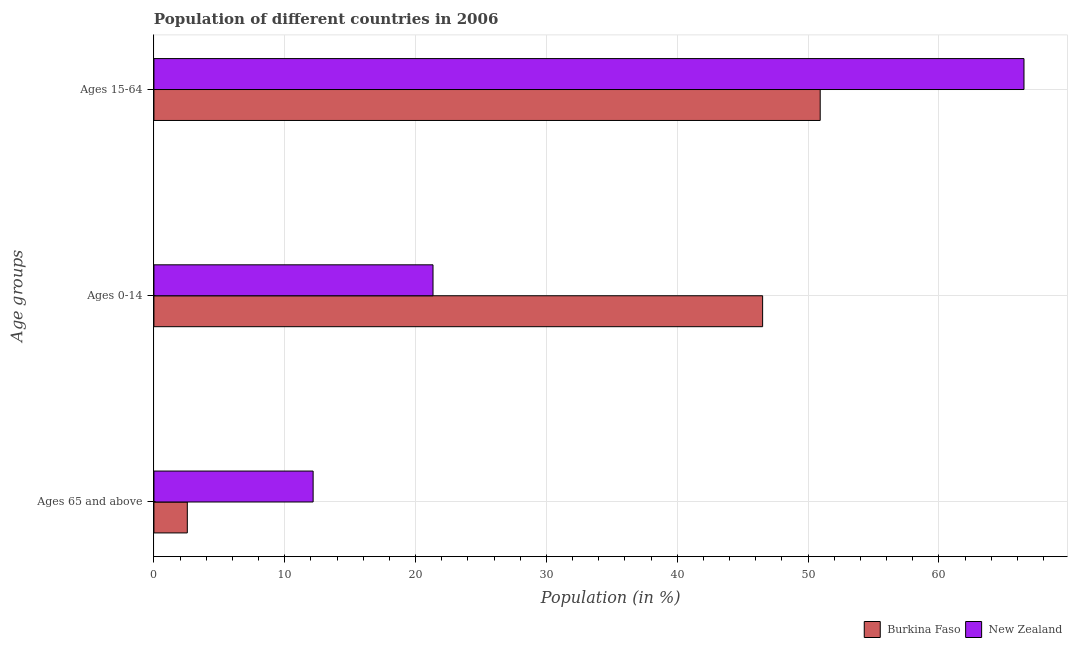How many groups of bars are there?
Your answer should be very brief. 3. Are the number of bars per tick equal to the number of legend labels?
Provide a succinct answer. Yes. How many bars are there on the 1st tick from the bottom?
Give a very brief answer. 2. What is the label of the 3rd group of bars from the top?
Offer a very short reply. Ages 65 and above. What is the percentage of population within the age-group of 65 and above in New Zealand?
Your answer should be very brief. 12.17. Across all countries, what is the maximum percentage of population within the age-group of 65 and above?
Offer a very short reply. 12.17. Across all countries, what is the minimum percentage of population within the age-group of 65 and above?
Keep it short and to the point. 2.55. In which country was the percentage of population within the age-group of 65 and above maximum?
Offer a terse response. New Zealand. In which country was the percentage of population within the age-group of 65 and above minimum?
Give a very brief answer. Burkina Faso. What is the total percentage of population within the age-group 0-14 in the graph?
Make the answer very short. 67.86. What is the difference between the percentage of population within the age-group of 65 and above in Burkina Faso and that in New Zealand?
Your answer should be compact. -9.62. What is the difference between the percentage of population within the age-group 0-14 in New Zealand and the percentage of population within the age-group 15-64 in Burkina Faso?
Offer a terse response. -29.59. What is the average percentage of population within the age-group of 65 and above per country?
Your answer should be compact. 7.36. What is the difference between the percentage of population within the age-group 0-14 and percentage of population within the age-group 15-64 in New Zealand?
Offer a very short reply. -45.17. In how many countries, is the percentage of population within the age-group 0-14 greater than 24 %?
Give a very brief answer. 1. What is the ratio of the percentage of population within the age-group 15-64 in New Zealand to that in Burkina Faso?
Your response must be concise. 1.31. Is the percentage of population within the age-group 0-14 in New Zealand less than that in Burkina Faso?
Your answer should be compact. Yes. What is the difference between the highest and the second highest percentage of population within the age-group 0-14?
Provide a short and direct response. 25.19. What is the difference between the highest and the lowest percentage of population within the age-group 15-64?
Your answer should be compact. 15.58. Is the sum of the percentage of population within the age-group of 65 and above in New Zealand and Burkina Faso greater than the maximum percentage of population within the age-group 0-14 across all countries?
Ensure brevity in your answer.  No. What does the 1st bar from the top in Ages 0-14 represents?
Ensure brevity in your answer.  New Zealand. What does the 1st bar from the bottom in Ages 65 and above represents?
Your answer should be very brief. Burkina Faso. Are the values on the major ticks of X-axis written in scientific E-notation?
Offer a terse response. No. Does the graph contain any zero values?
Give a very brief answer. No. How are the legend labels stacked?
Your response must be concise. Horizontal. What is the title of the graph?
Give a very brief answer. Population of different countries in 2006. Does "Moldova" appear as one of the legend labels in the graph?
Provide a succinct answer. No. What is the label or title of the X-axis?
Ensure brevity in your answer.  Population (in %). What is the label or title of the Y-axis?
Your response must be concise. Age groups. What is the Population (in %) in Burkina Faso in Ages 65 and above?
Your response must be concise. 2.55. What is the Population (in %) in New Zealand in Ages 65 and above?
Your answer should be very brief. 12.17. What is the Population (in %) in Burkina Faso in Ages 0-14?
Offer a very short reply. 46.52. What is the Population (in %) in New Zealand in Ages 0-14?
Your answer should be compact. 21.33. What is the Population (in %) in Burkina Faso in Ages 15-64?
Your response must be concise. 50.92. What is the Population (in %) in New Zealand in Ages 15-64?
Give a very brief answer. 66.5. Across all Age groups, what is the maximum Population (in %) in Burkina Faso?
Give a very brief answer. 50.92. Across all Age groups, what is the maximum Population (in %) in New Zealand?
Provide a short and direct response. 66.5. Across all Age groups, what is the minimum Population (in %) in Burkina Faso?
Make the answer very short. 2.55. Across all Age groups, what is the minimum Population (in %) of New Zealand?
Your response must be concise. 12.17. What is the total Population (in %) in Burkina Faso in the graph?
Your answer should be very brief. 100. What is the total Population (in %) in New Zealand in the graph?
Offer a terse response. 100. What is the difference between the Population (in %) in Burkina Faso in Ages 65 and above and that in Ages 0-14?
Your response must be concise. -43.97. What is the difference between the Population (in %) of New Zealand in Ages 65 and above and that in Ages 0-14?
Make the answer very short. -9.16. What is the difference between the Population (in %) of Burkina Faso in Ages 65 and above and that in Ages 15-64?
Offer a very short reply. -48.37. What is the difference between the Population (in %) of New Zealand in Ages 65 and above and that in Ages 15-64?
Offer a very short reply. -54.33. What is the difference between the Population (in %) in Burkina Faso in Ages 0-14 and that in Ages 15-64?
Your answer should be compact. -4.4. What is the difference between the Population (in %) of New Zealand in Ages 0-14 and that in Ages 15-64?
Offer a very short reply. -45.17. What is the difference between the Population (in %) of Burkina Faso in Ages 65 and above and the Population (in %) of New Zealand in Ages 0-14?
Make the answer very short. -18.78. What is the difference between the Population (in %) in Burkina Faso in Ages 65 and above and the Population (in %) in New Zealand in Ages 15-64?
Provide a succinct answer. -63.95. What is the difference between the Population (in %) in Burkina Faso in Ages 0-14 and the Population (in %) in New Zealand in Ages 15-64?
Make the answer very short. -19.98. What is the average Population (in %) of Burkina Faso per Age groups?
Provide a succinct answer. 33.33. What is the average Population (in %) of New Zealand per Age groups?
Your answer should be very brief. 33.33. What is the difference between the Population (in %) in Burkina Faso and Population (in %) in New Zealand in Ages 65 and above?
Give a very brief answer. -9.62. What is the difference between the Population (in %) in Burkina Faso and Population (in %) in New Zealand in Ages 0-14?
Give a very brief answer. 25.19. What is the difference between the Population (in %) of Burkina Faso and Population (in %) of New Zealand in Ages 15-64?
Your answer should be very brief. -15.58. What is the ratio of the Population (in %) of Burkina Faso in Ages 65 and above to that in Ages 0-14?
Your response must be concise. 0.05. What is the ratio of the Population (in %) of New Zealand in Ages 65 and above to that in Ages 0-14?
Give a very brief answer. 0.57. What is the ratio of the Population (in %) of Burkina Faso in Ages 65 and above to that in Ages 15-64?
Provide a succinct answer. 0.05. What is the ratio of the Population (in %) in New Zealand in Ages 65 and above to that in Ages 15-64?
Your answer should be very brief. 0.18. What is the ratio of the Population (in %) of Burkina Faso in Ages 0-14 to that in Ages 15-64?
Keep it short and to the point. 0.91. What is the ratio of the Population (in %) of New Zealand in Ages 0-14 to that in Ages 15-64?
Give a very brief answer. 0.32. What is the difference between the highest and the second highest Population (in %) in Burkina Faso?
Offer a terse response. 4.4. What is the difference between the highest and the second highest Population (in %) of New Zealand?
Make the answer very short. 45.17. What is the difference between the highest and the lowest Population (in %) in Burkina Faso?
Your response must be concise. 48.37. What is the difference between the highest and the lowest Population (in %) of New Zealand?
Offer a terse response. 54.33. 